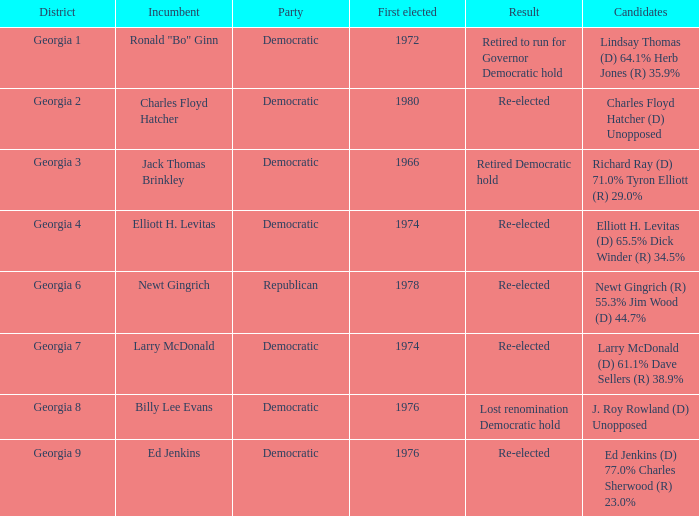Name the districk for larry mcdonald Georgia 7. 